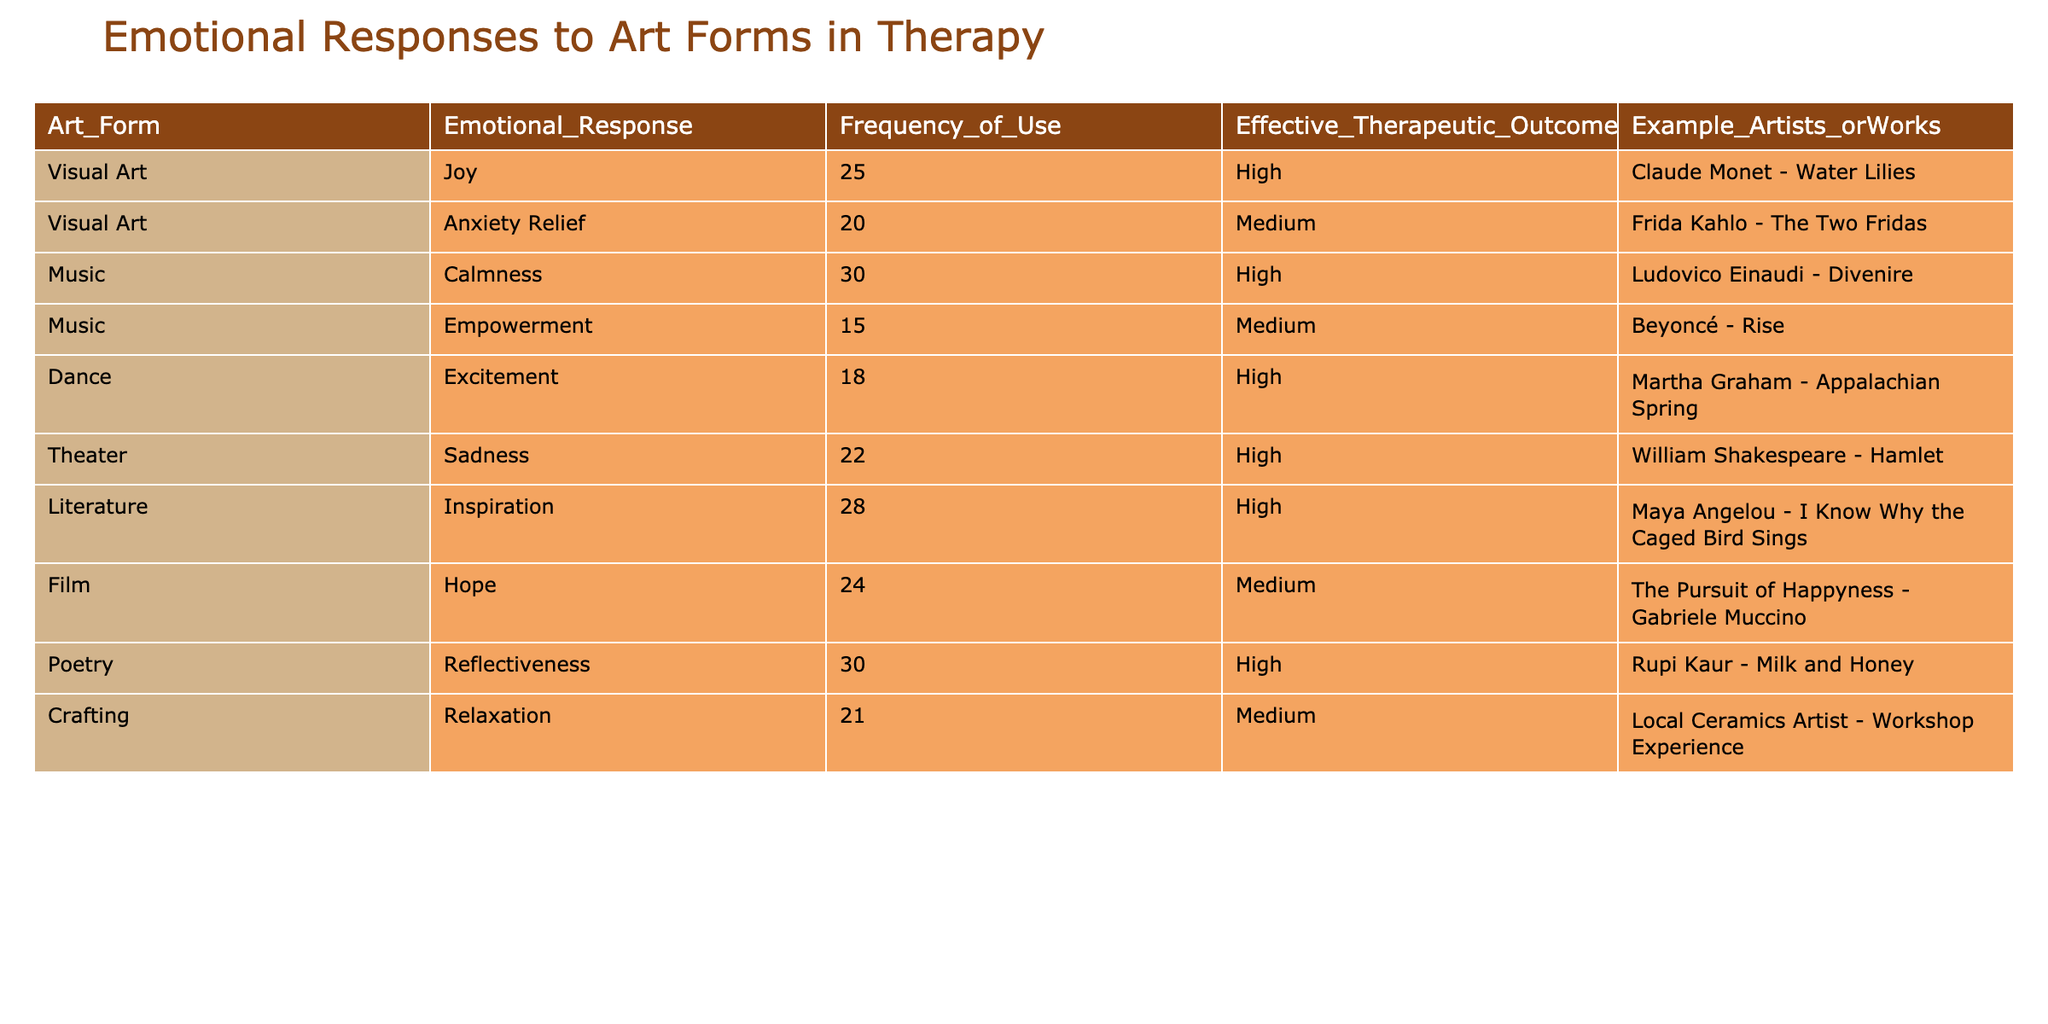What is the emotional response associated with visual art? By looking at the "Emotional_Response" column for the "Visual Art" row, we can see it states "Joy."
Answer: Joy Which art form has the highest frequency of use? The "Frequency_of_Use" column indicates that "Poetry" and "Music" both have the highest frequency (30), but "Poetry" also appears under "Calmness" (still 30 for Music). So, the answer is tied between those two.
Answer: Poetry and Music What is the effective therapeutic outcome for Frida Kahlo's "The Two Fridas"? Referring to the row indicating "Frida Kahlo - The Two Fridas," the "Effective_Therapeutic_Outcome" column shows "Medium."
Answer: Medium Is crafting associated with relaxation as an emotional response in this table? Looking at the "Emotional_Response" column for "Crafting," it indeed states "Relaxation," which confirms the association.
Answer: Yes What is the average frequency of use for art forms that have a high effective therapeutic outcome? First, identify the art forms with a "High" outcome: Visual Art (25), Music (30), Dance (18), Theater (22), Literature (28), Poetry (30). Then, sum these: (25 + 30 + 18 + 22 + 28 + 30 = 153). Finally, divide by the number of forms, which is 6: 153/6 = 25.5.
Answer: 25.5 Which art form shows the most varied emotional responses and their frequencies? By examining the table, "Visual Art" shows two distinct emotional responses—Joy (25) and Anxiety Relief (20), making it the most varied among the entries.
Answer: Visual Art What artist or work is associated with the emotional response of sadness? In scanning the entries under the "Emotional_Response" column, "Theater" with "Sadness" cites "William Shakespeare - Hamlet" in the "Example_Artists_orWorks" column.
Answer: William Shakespeare - Hamlet How many art forms have an effective therapeutic outcome rated as "Medium"? Count the number of occurrences of "Medium" in the "Effective_Therapeutic_Outcome" column: Anxiety Relief (20), Empowerment (15), Film (24), Crafting (21) equals a total of 4.
Answer: 4 What unique emotional response is associated with dance, and how does it affect therapeutic outcomes? Checking the "Dance" row, it shows "Excitement" under the "Emotional_Response" and a "High" effective therapeutic outcome, indicating it may evoke significant emotional engagement in therapy.
Answer: Excitement, High 